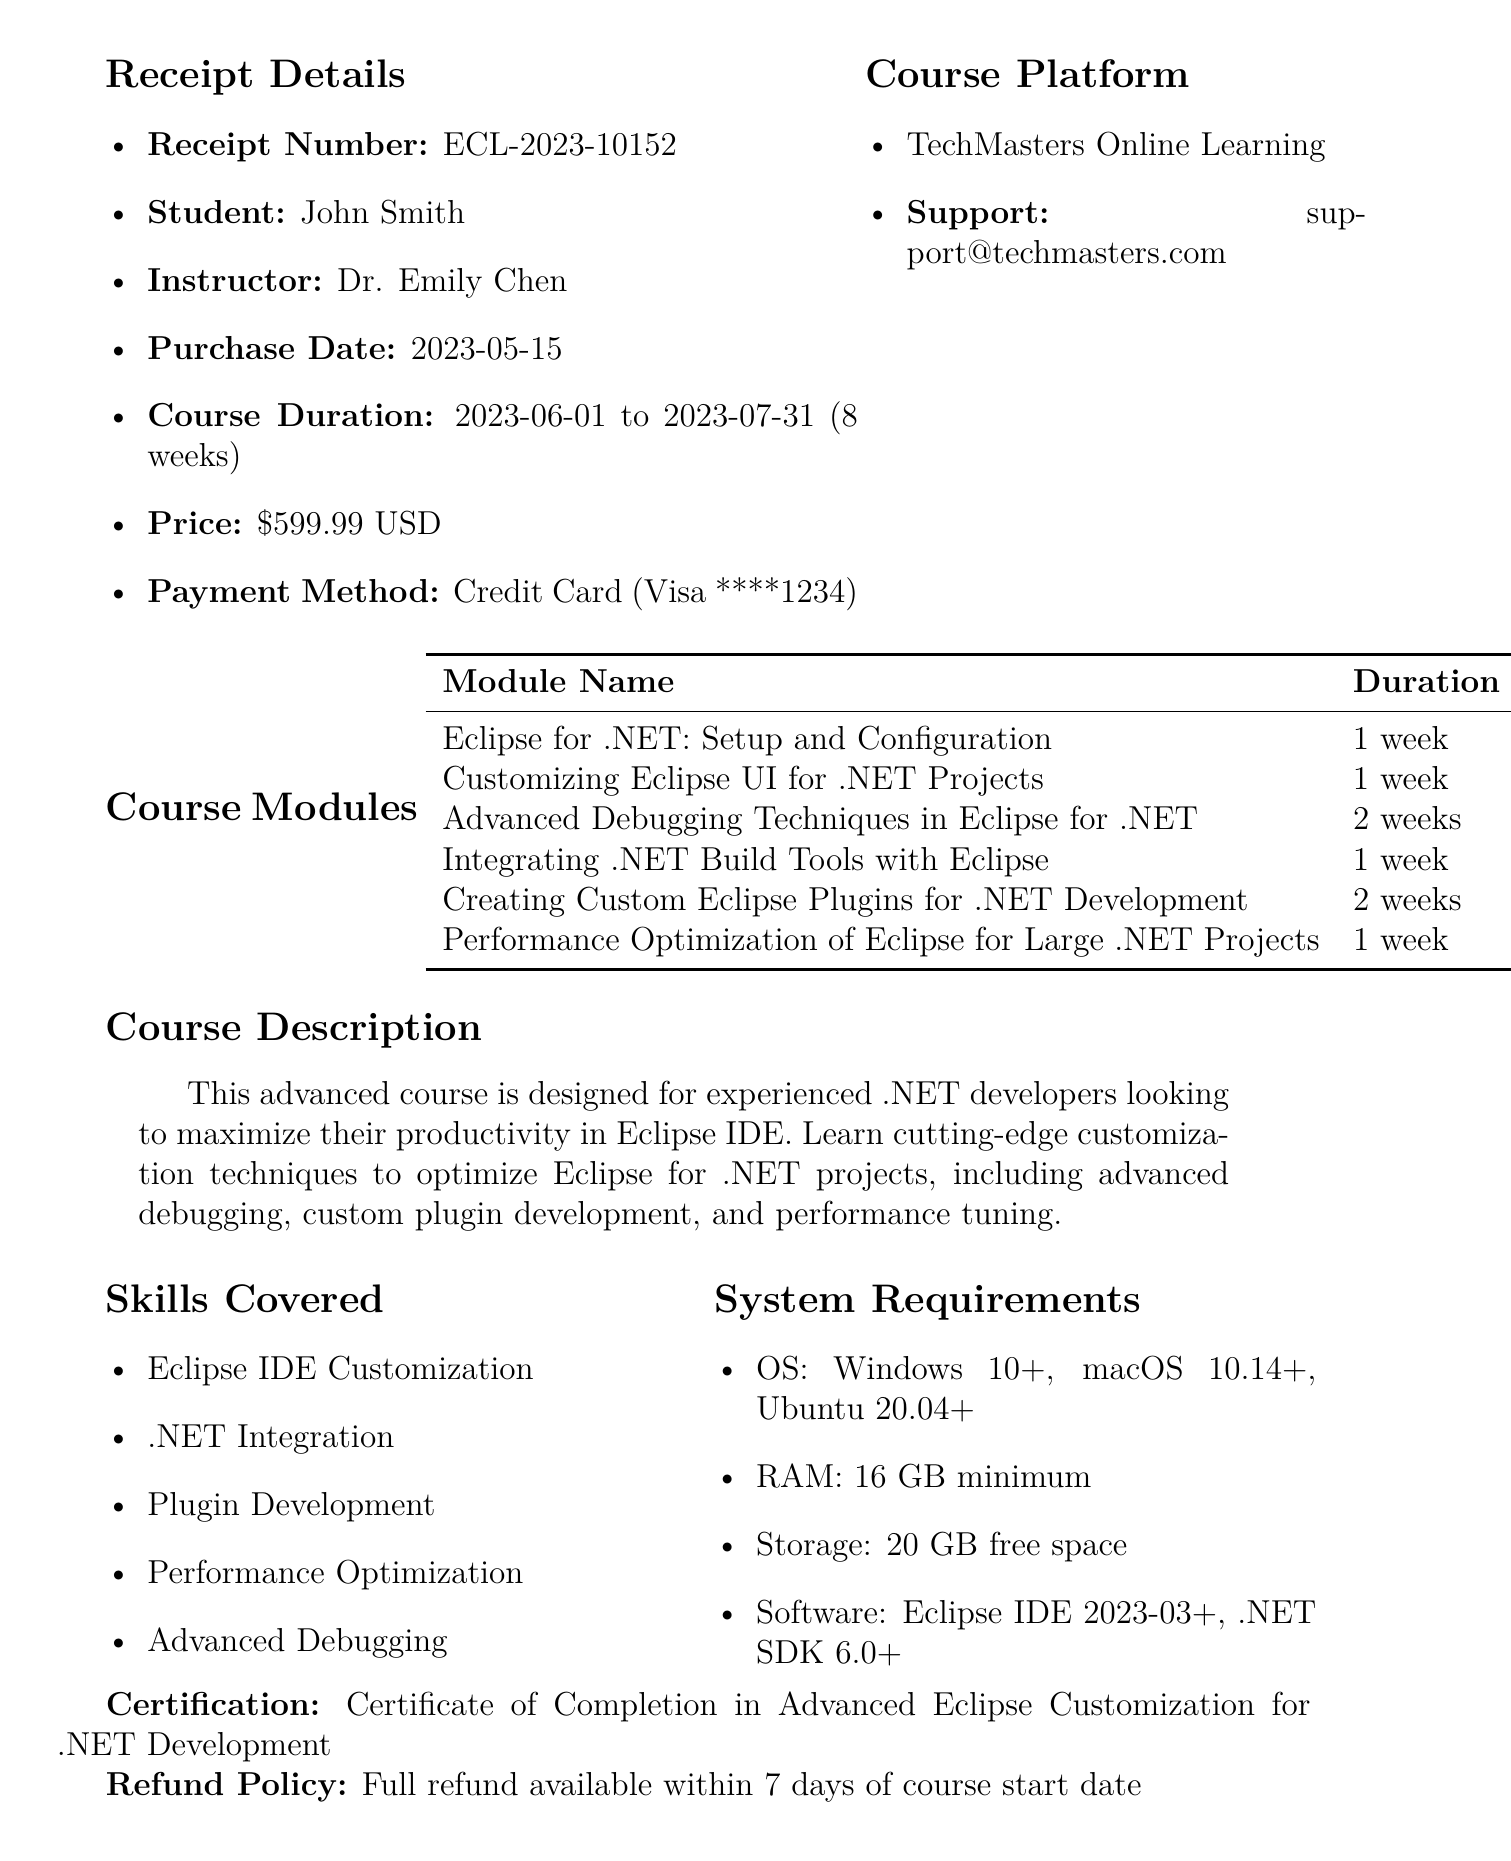What is the receipt number? The receipt number is a specific identifier for the transaction, represented in the document as "ECL-2023-10152".
Answer: ECL-2023-10152 Who is the student enrolled in the course? The document lists the name of the student who purchased the course, which is "John Smith".
Answer: John Smith What is the total duration of the course? The total duration of the course is specified in the document as "8 weeks".
Answer: 8 weeks How many weeks is the module "Advanced Debugging Techniques in Eclipse for .NET"? The duration for this module is mentioned in the document as "2 weeks".
Answer: 2 weeks What payment method was used for the course? The payment method, as stated in the document, is "Credit Card (Visa ****1234)".
Answer: Credit Card (Visa ****1234) What is the certification awarded upon course completion? The document specifies the certification as "Certificate of Completion in Advanced Eclipse Customization for .NET Development".
Answer: Certificate of Completion in Advanced Eclipse Customization for .NET Development Which email address can be used for support? The support email provided in the document is "support@techmasters.com".
Answer: support@techmasters.com What refund policy is mentioned in the document? The document states the refund policy, indicating a "Full refund available within 7 days of course start date".
Answer: Full refund available within 7 days of course start date What is the course platform for this online course? The course platform mentioned in the document is "TechMasters Online Learning".
Answer: TechMasters Online Learning 